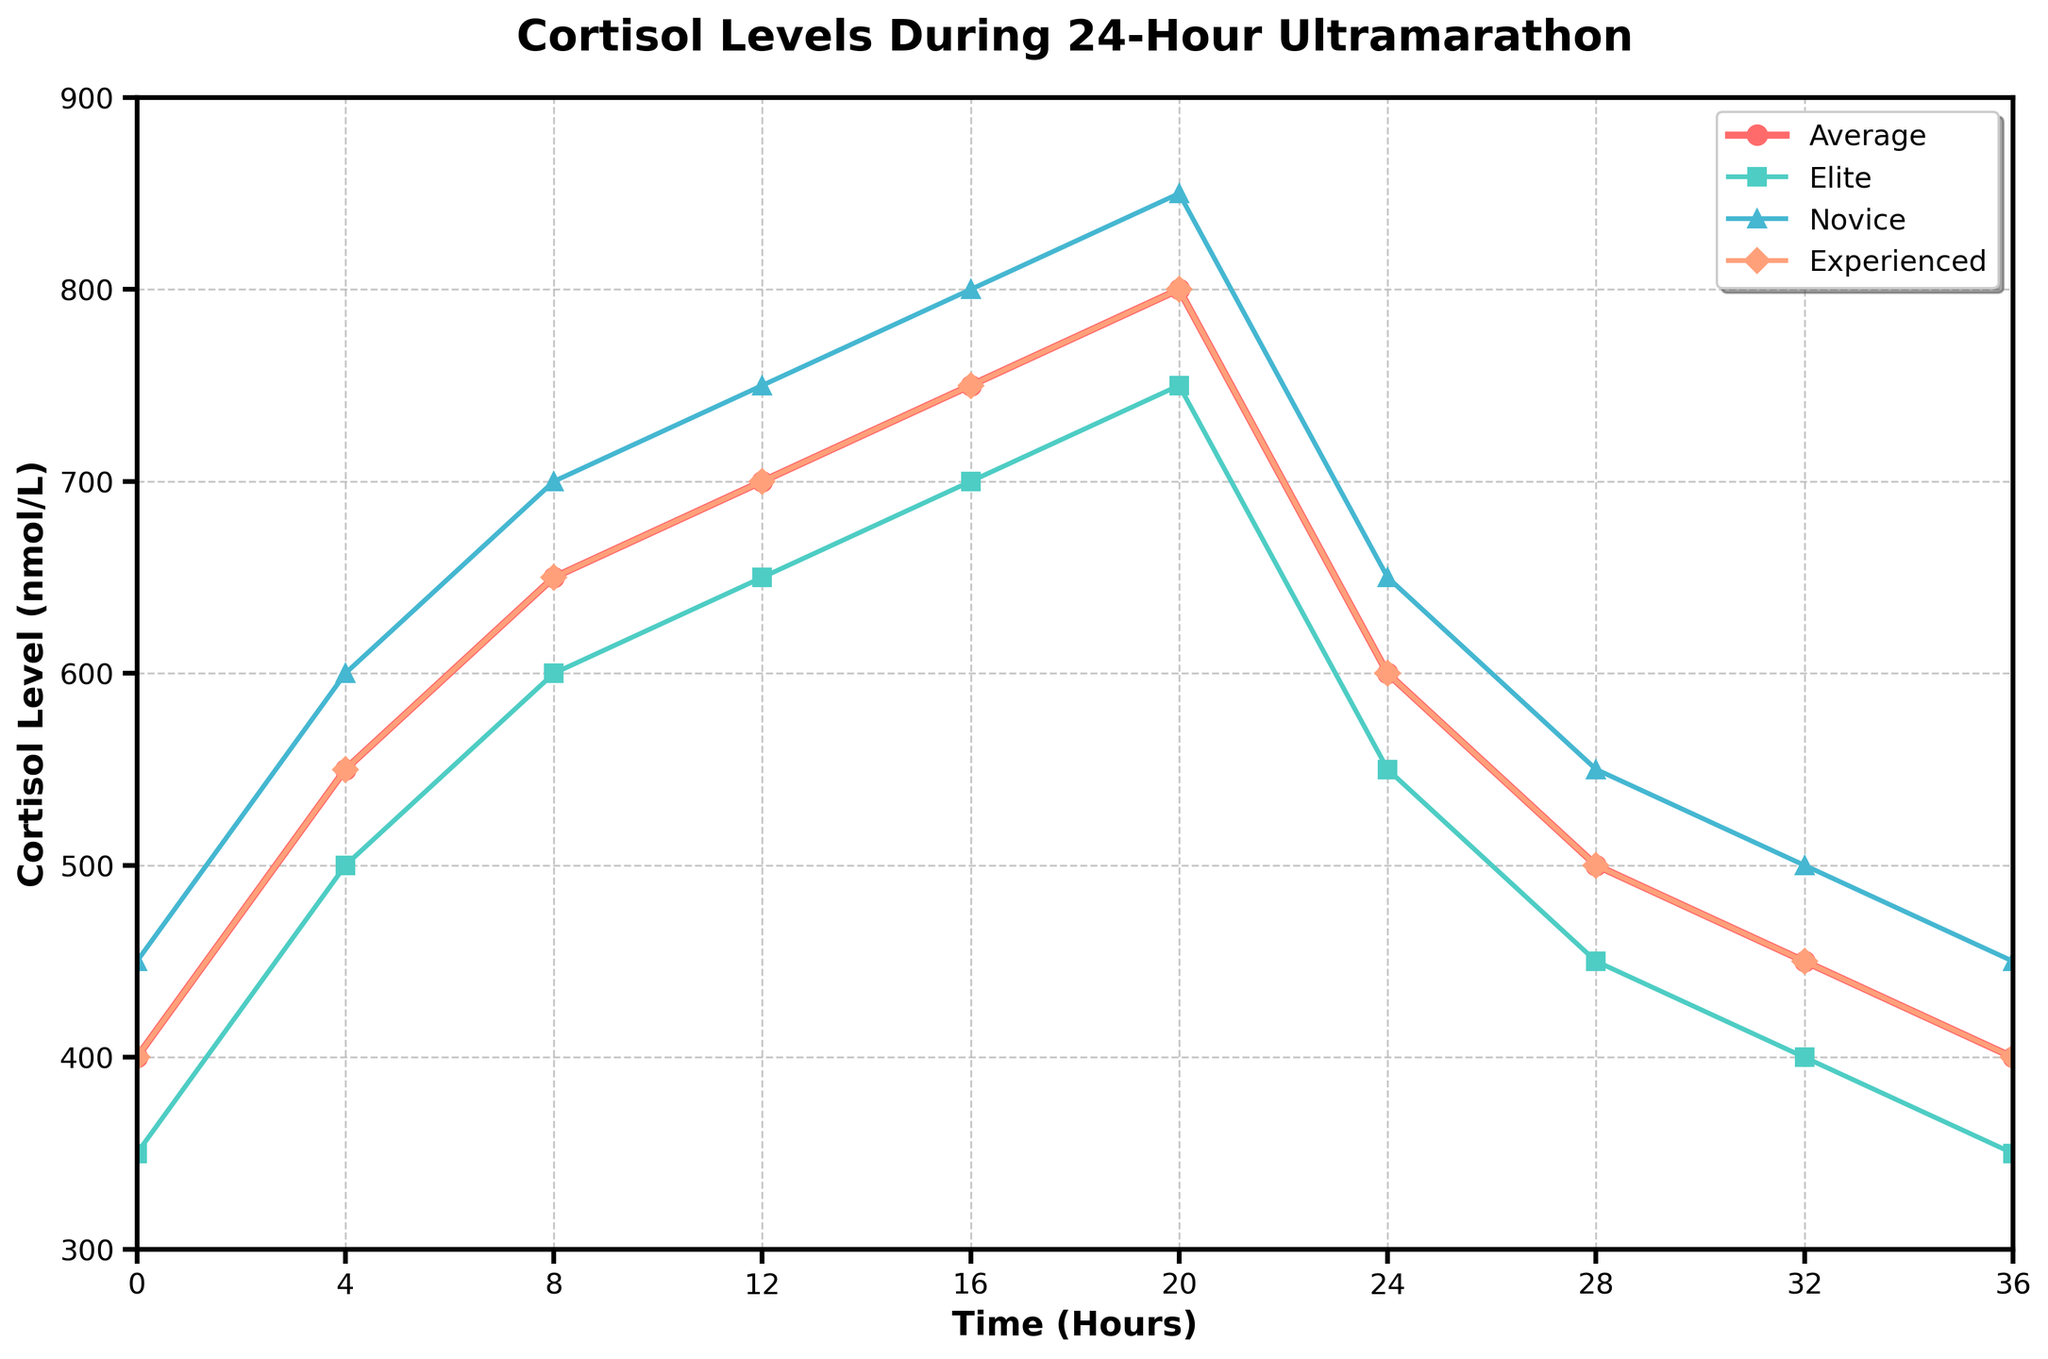What's the peak Cortisol level for the average group, and at what time does it occur? The average group's Cortisol level peaks at 800 nmol/L and occurs at the 20th hour. Refer to the highest point on the red line, which is labeled "Average," to determine both the peak value and the corresponding time.
Answer: 800 nmol/L at the 20th hour Which runner group shows the most significant increase in Cortisol levels between 0 and 8 hours? To determine this, examine the difference in Cortisol levels for each runner group between 0 and 8 hours. The elite runner group increases from 350 to 600 nmol/L (250 nmol/L), the novice runner group increases from 450 to 700 nmol/L (250 nmol/L), and the experienced runner group increases from 400 to 650 nmol/L (250 nmol/L). Thus, all groups show the same increase of 250 nmol/L.
Answer: They all increase equally, by 250 nmol/L At hour 24, how do the Cortisol levels of the novice and experienced runners compare? At hour 24, the novice runner group has a Cortisol level of 650 nmol/L, while the experienced runner group has 600 nmol/L. The figure shows these values clearly on the Y-axis for the respective time point.
Answer: Novice: 650 nmol/L, Experienced: 600 nmol/L What's the average decrease in Cortisol levels from the peak (20 hours) to the end (36 hours) for the elite runners? The elite runners' Cortisol level peaks at 750 nmol/L at 20 hours and decreases to 350 nmol/L at 36 hours. The average decrease is calculated by taking the difference between these two levels: 750 - 350 = 400 nmol/L. Therefore, the average decrease is 400 nmol/L over the 16-hour period.
Answer: 400 nmol/L Which runner group consistently shows the highest Cortisol levels throughout the ultramarathon? Observing the figure, the novice runner group (depicted with blue triangles) shows higher Cortisol levels than the elite and experienced runner groups at every time point. Follow the blue line and compare it visually with the other lines to confirm this observation.
Answer: Novice runner group Between hours 16 and 20, which group shows the smallest change in Cortisol levels? From hour 16 to 20, the elite runner group changes from 700 to 750 nmol/L (50 nmol/L), the novice runner group changes from 800 to 850 nmol/L (50 nmol/L), and the experienced runner group changes from 750 to 800 nmol/L (50 nmol/L). Therefore, all groups show the same change in Cortisol levels.
Answer: They all show the same change, 50 nmol/L What is the range of Cortisol levels for the average group? The range is calculated as the difference between the maximum and minimum values of the average group's Cortisol levels. The maximum value is 800 nmol/L (at 20 hours) and the minimum is 400 nmol/L (at 0 and 36 hours). Therefore, the range is 800 - 400 = 400 nmol/L.
Answer: 400 nmol/L At what time does the experienced runner group begin to show a decrease in Cortisol levels after their peak? The experienced runner group's Cortisol level peaks at 800 nmol/L at the 20th hour. The levels begin to decrease starting at the next time point, which is 24 hours. Observe the orange line's decline after the peak at 20 hours.
Answer: 24 hours 